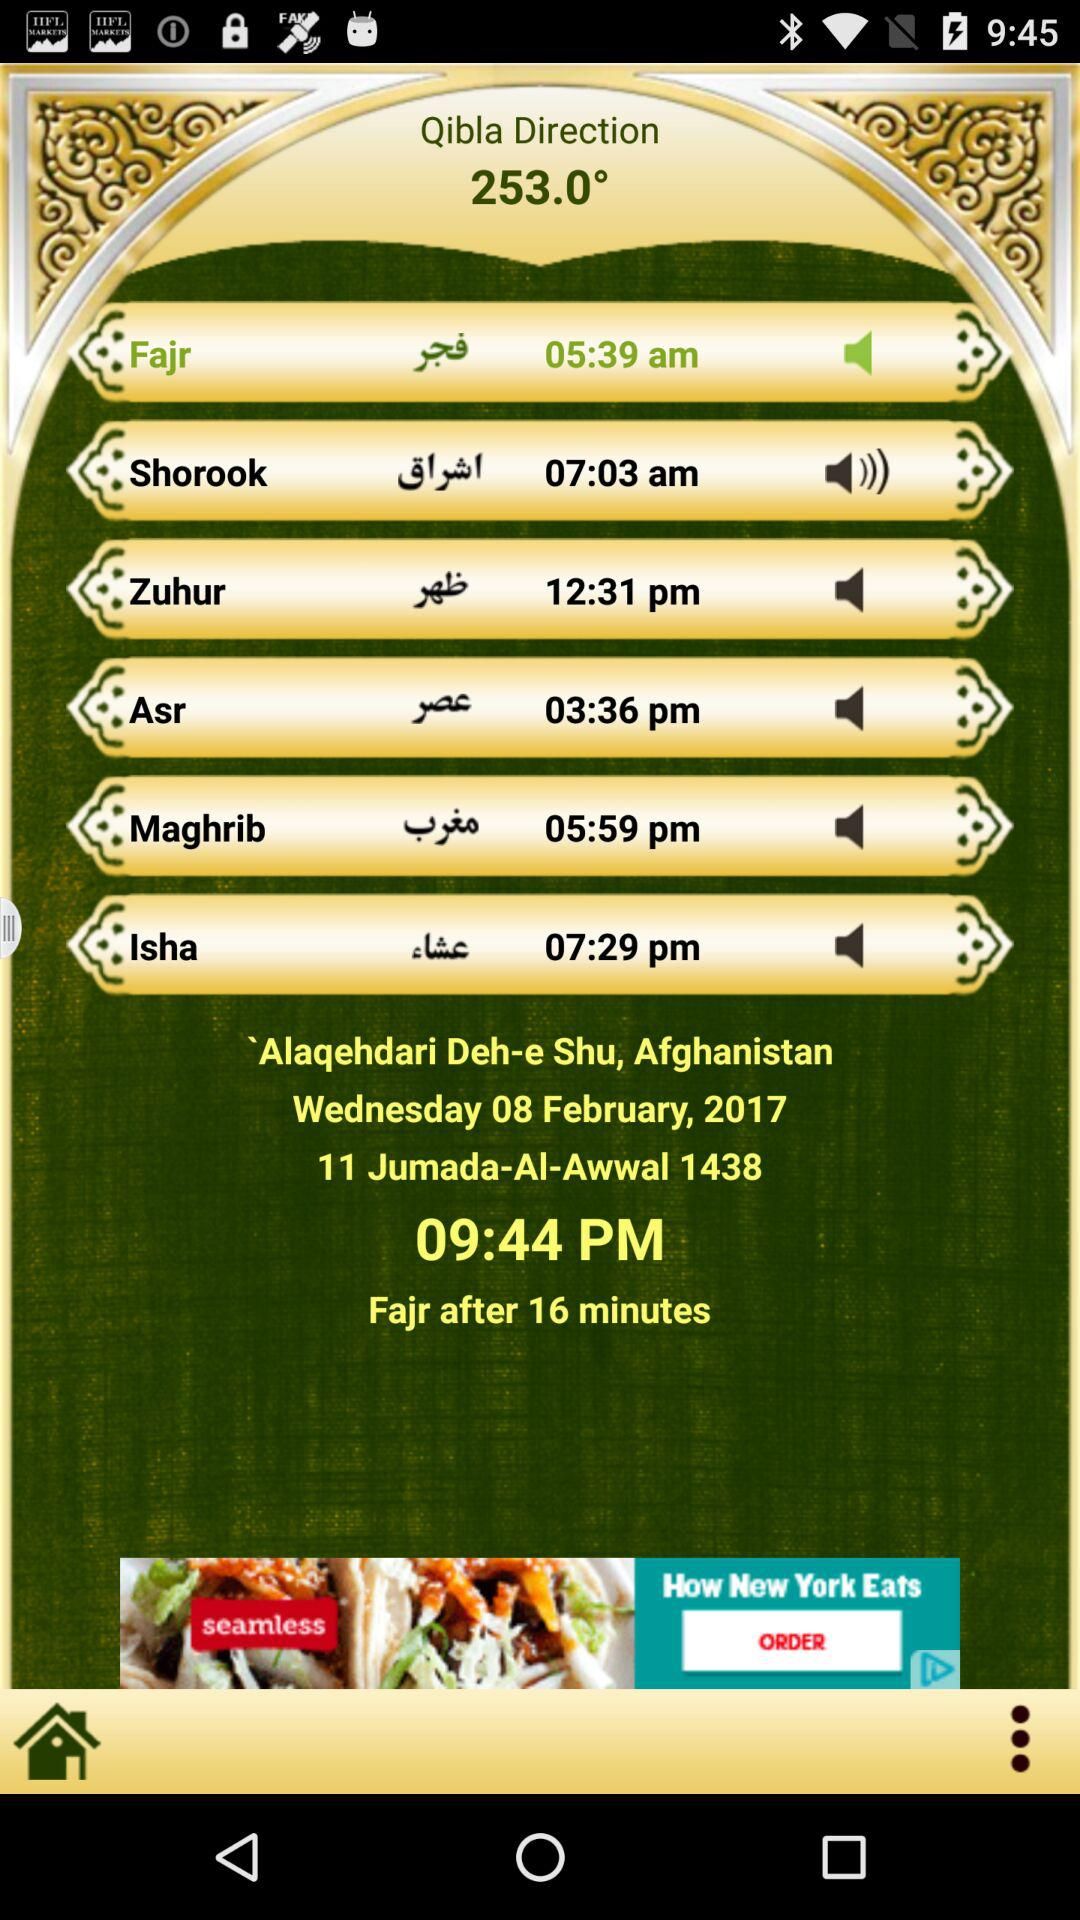What date is displayed on the screen? The date is Wednesday, February 8, 2017. 